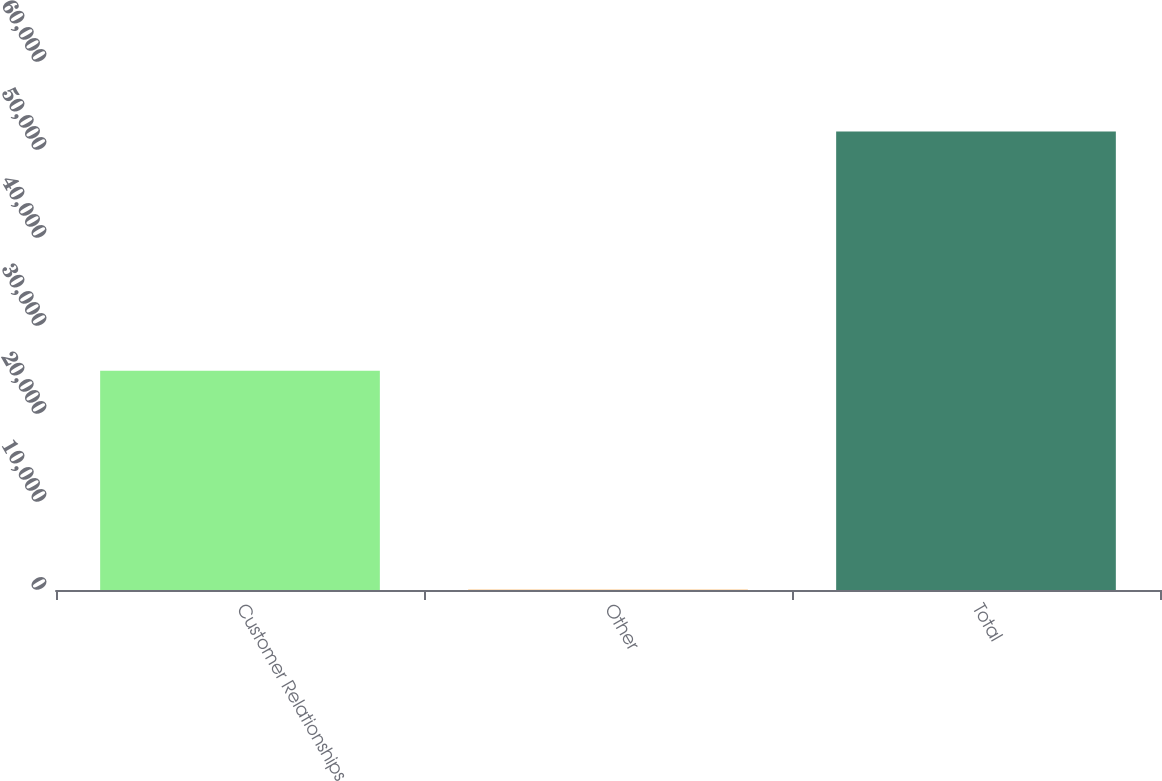Convert chart. <chart><loc_0><loc_0><loc_500><loc_500><bar_chart><fcel>Customer Relationships<fcel>Other<fcel>Total<nl><fcel>24927<fcel>21<fcel>52114<nl></chart> 